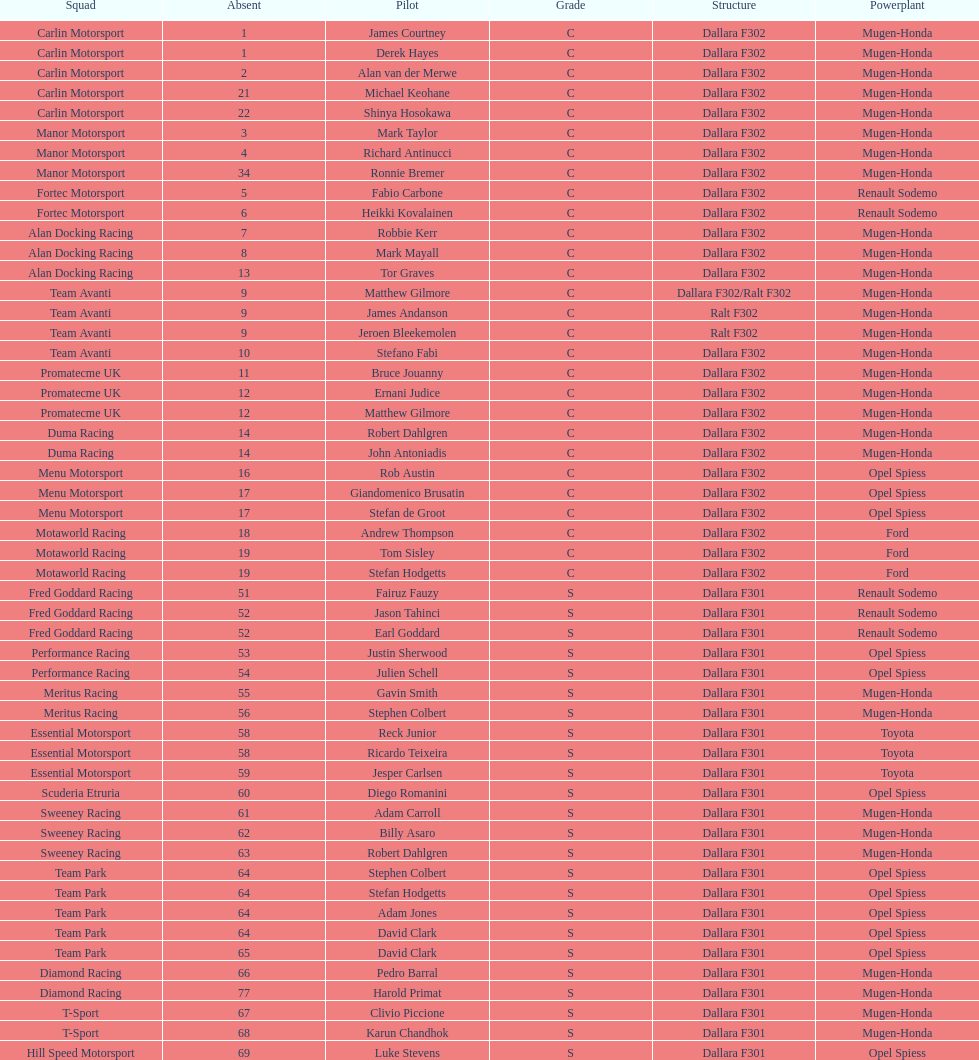What is the mean count of teams that possessed a mugen-honda engine? 24. 